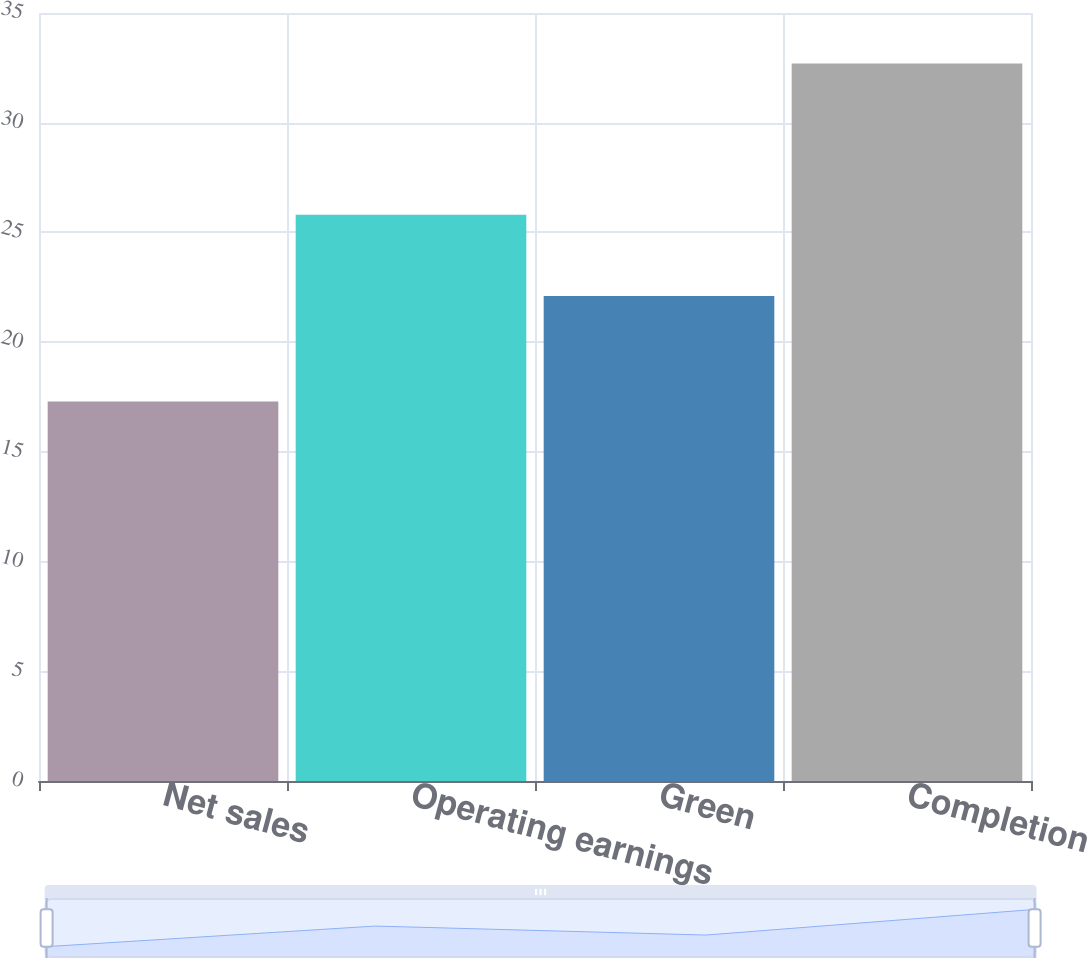Convert chart. <chart><loc_0><loc_0><loc_500><loc_500><bar_chart><fcel>Net sales<fcel>Operating earnings<fcel>Green<fcel>Completion<nl><fcel>17.3<fcel>25.8<fcel>22.1<fcel>32.7<nl></chart> 